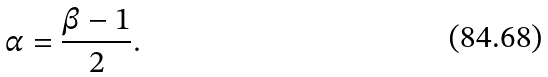Convert formula to latex. <formula><loc_0><loc_0><loc_500><loc_500>\alpha = \frac { \beta - 1 } { 2 } .</formula> 